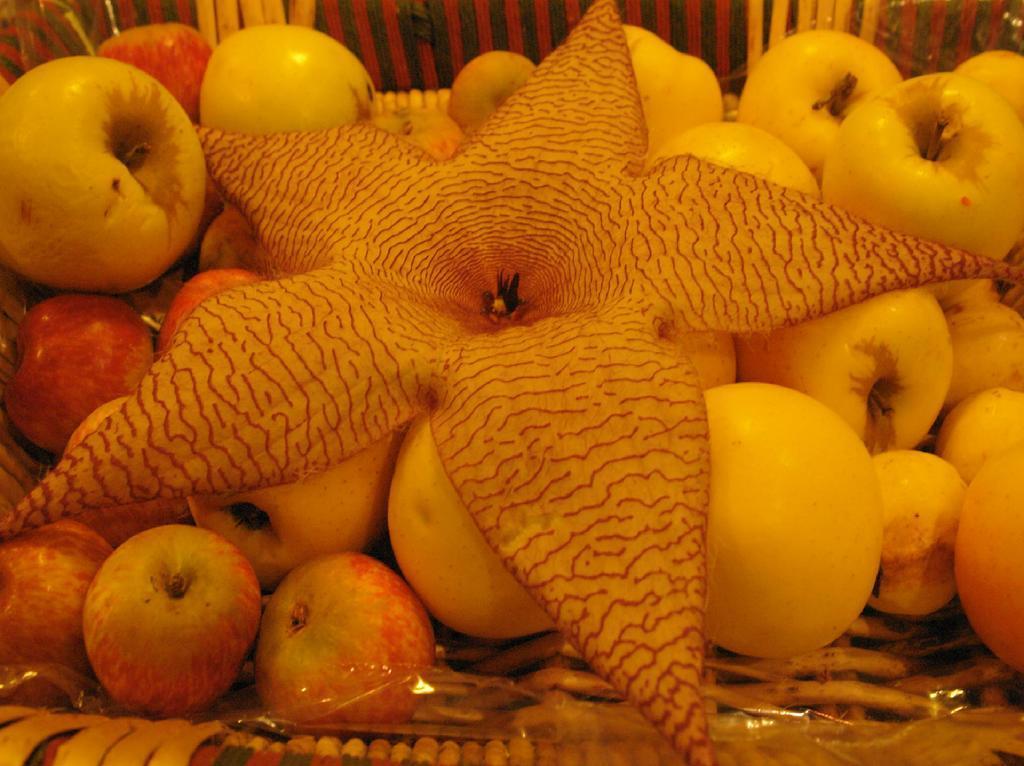Describe this image in one or two sentences. In the middle of the image there are many apples and a flower in the basket. 